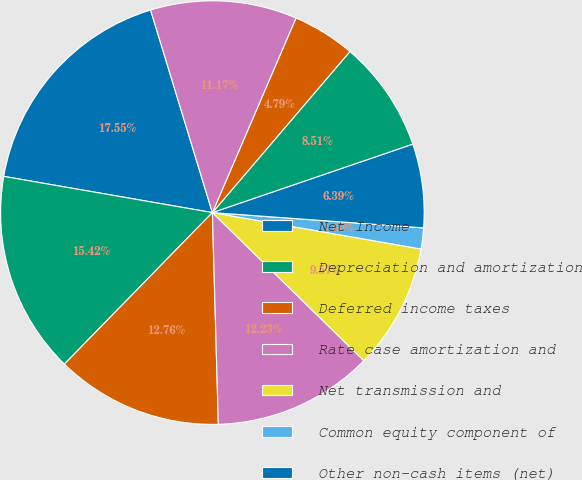Convert chart to OTSL. <chart><loc_0><loc_0><loc_500><loc_500><pie_chart><fcel>Net Income<fcel>Depreciation and amortization<fcel>Deferred income taxes<fcel>Rate case amortization and<fcel>Net transmission and<fcel>Common equity component of<fcel>Other non-cash items (net)<fcel>Accounts receivable-customers<fcel>Materials and supplies<fcel>Other receivables and other<nl><fcel>17.55%<fcel>15.42%<fcel>12.76%<fcel>12.23%<fcel>9.57%<fcel>1.6%<fcel>6.39%<fcel>8.51%<fcel>4.79%<fcel>11.17%<nl></chart> 